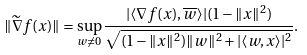<formula> <loc_0><loc_0><loc_500><loc_500>\| \widetilde { \nabla } f ( x ) \| = \sup _ { w \ne 0 } \frac { | \langle \nabla f ( x ) , { \overline { w } } \rangle | ( 1 - \| x \| ^ { 2 } ) } { \sqrt { ( 1 - \| x \| ^ { 2 } ) \| w \| ^ { 2 } + | \langle w , x \rangle | ^ { 2 } } } .</formula> 